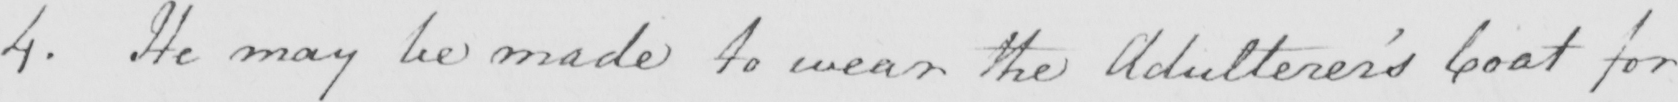Can you read and transcribe this handwriting? 4 . He may be made to wear the Adulterer ' s Coat for 